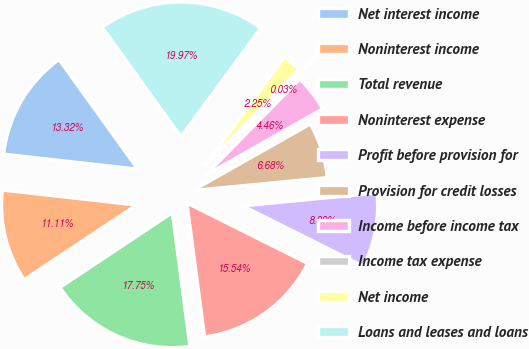Convert chart. <chart><loc_0><loc_0><loc_500><loc_500><pie_chart><fcel>Net interest income<fcel>Noninterest income<fcel>Total revenue<fcel>Noninterest expense<fcel>Profit before provision for<fcel>Provision for credit losses<fcel>Income before income tax<fcel>Income tax expense<fcel>Net income<fcel>Loans and leases and loans<nl><fcel>13.32%<fcel>11.11%<fcel>17.75%<fcel>15.54%<fcel>8.89%<fcel>6.68%<fcel>4.46%<fcel>0.03%<fcel>2.25%<fcel>19.97%<nl></chart> 